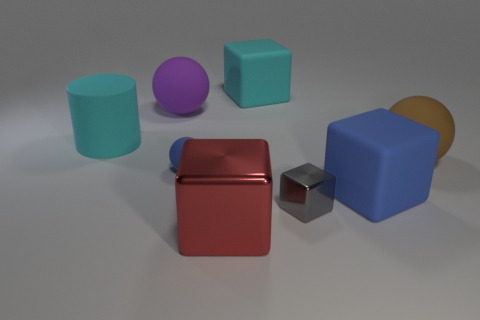What size is the brown rubber object?
Keep it short and to the point. Large. The small rubber thing is what shape?
Make the answer very short. Sphere. There is a big shiny thing; does it have the same shape as the shiny object that is behind the red metal cube?
Your response must be concise. Yes. There is a large cyan thing that is left of the small matte object; is it the same shape as the brown object?
Offer a terse response. No. What number of things are both on the left side of the purple object and right of the matte cylinder?
Provide a succinct answer. 0. How many other objects are the same size as the purple sphere?
Offer a terse response. 5. Are there the same number of brown rubber things that are in front of the big blue block and rubber cylinders?
Provide a short and direct response. No. There is a shiny object that is on the left side of the small gray block; is its color the same as the sphere that is in front of the brown sphere?
Your answer should be very brief. No. The sphere that is behind the tiny matte ball and in front of the big purple matte object is made of what material?
Provide a short and direct response. Rubber. The small metal object is what color?
Your answer should be very brief. Gray. 